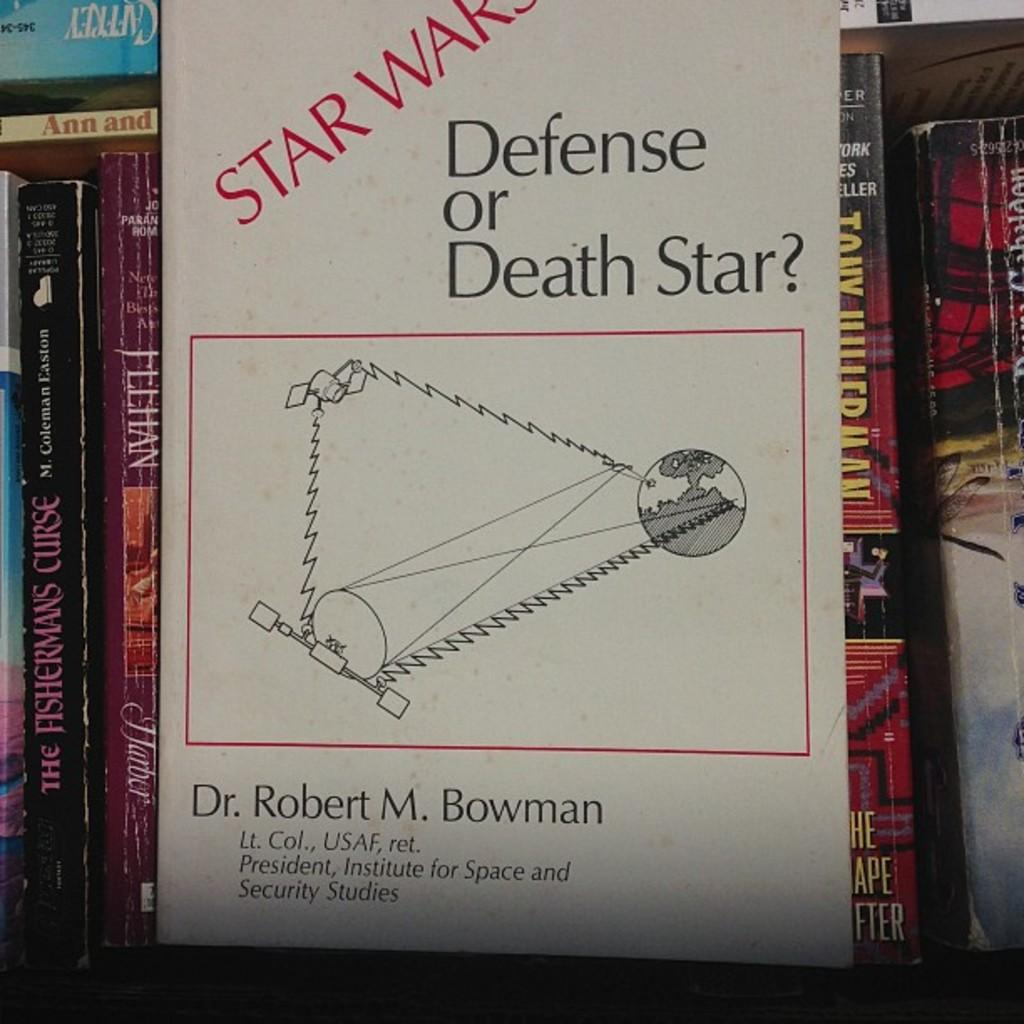<image>
Summarize the visual content of the image. A book that is titled Star Wars Defense or Death Star. 